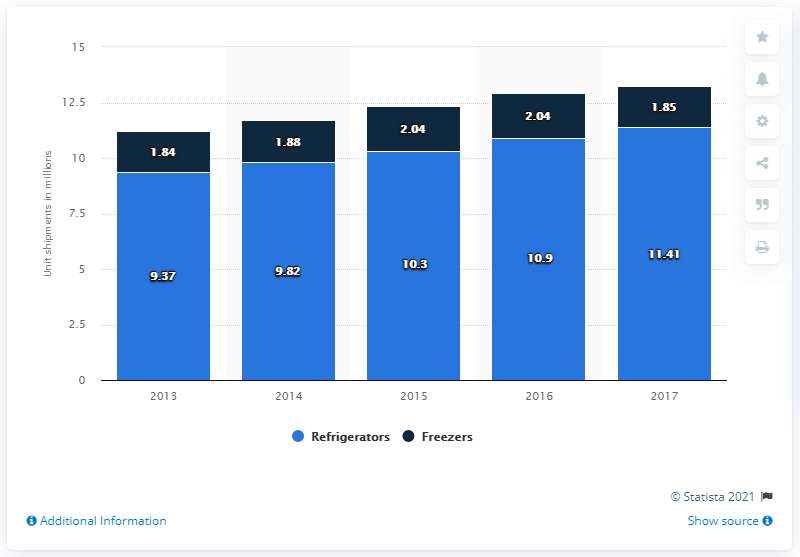Identify some key points in this picture. In 2017, 11,410 refrigerators were shipped in the United States. 